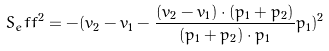<formula> <loc_0><loc_0><loc_500><loc_500>S _ { e } f f ^ { 2 } = - ( v _ { 2 } - v _ { 1 } - \frac { ( v _ { 2 } - v _ { 1 } ) \cdot ( p _ { 1 } + p _ { 2 } ) } { ( p _ { 1 } + p _ { 2 } ) \cdot p _ { 1 } } p _ { 1 } ) ^ { 2 }</formula> 